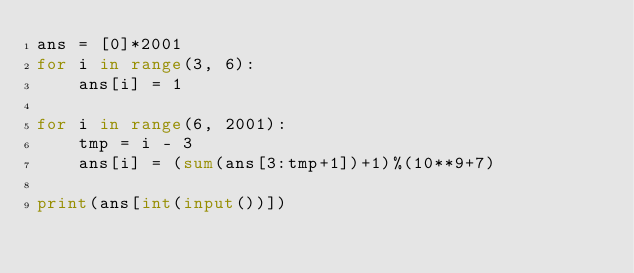<code> <loc_0><loc_0><loc_500><loc_500><_Python_>ans = [0]*2001
for i in range(3, 6):
    ans[i] = 1

for i in range(6, 2001):
    tmp = i - 3
    ans[i] = (sum(ans[3:tmp+1])+1)%(10**9+7)
    
print(ans[int(input())])</code> 